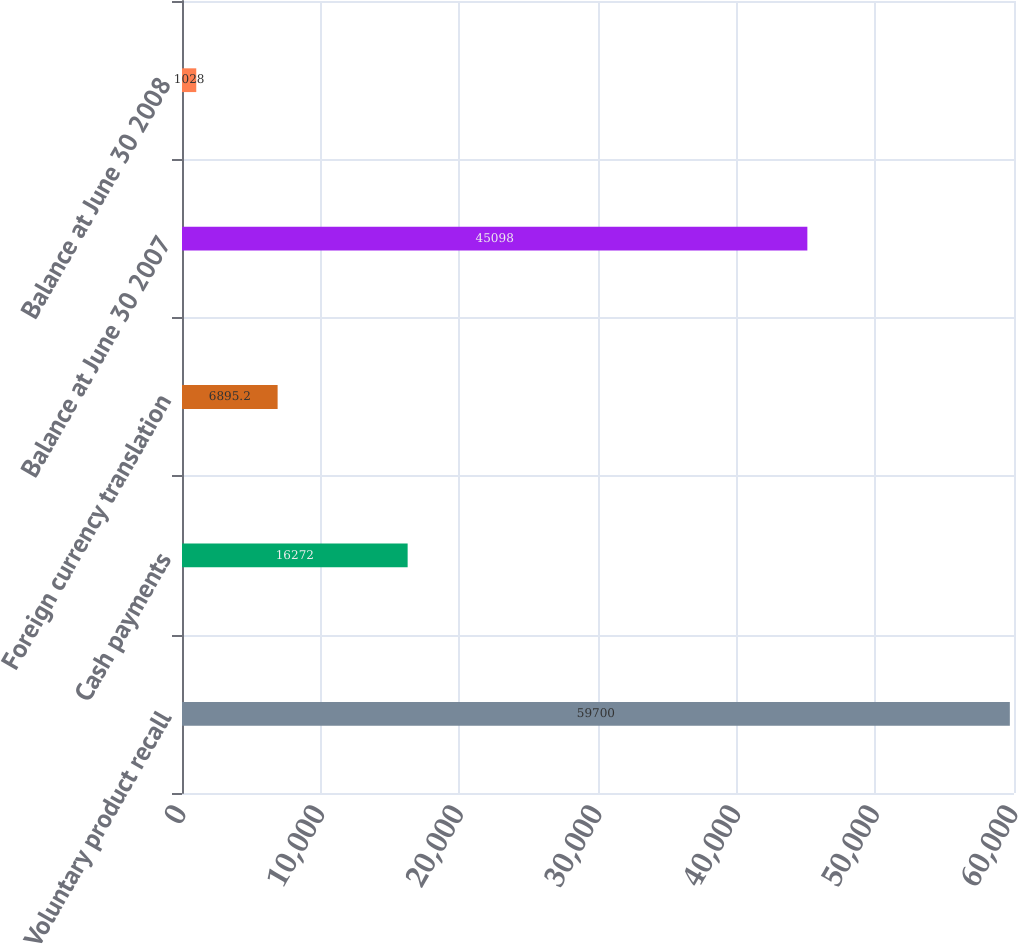Convert chart to OTSL. <chart><loc_0><loc_0><loc_500><loc_500><bar_chart><fcel>Voluntary product recall<fcel>Cash payments<fcel>Foreign currency translation<fcel>Balance at June 30 2007<fcel>Balance at June 30 2008<nl><fcel>59700<fcel>16272<fcel>6895.2<fcel>45098<fcel>1028<nl></chart> 